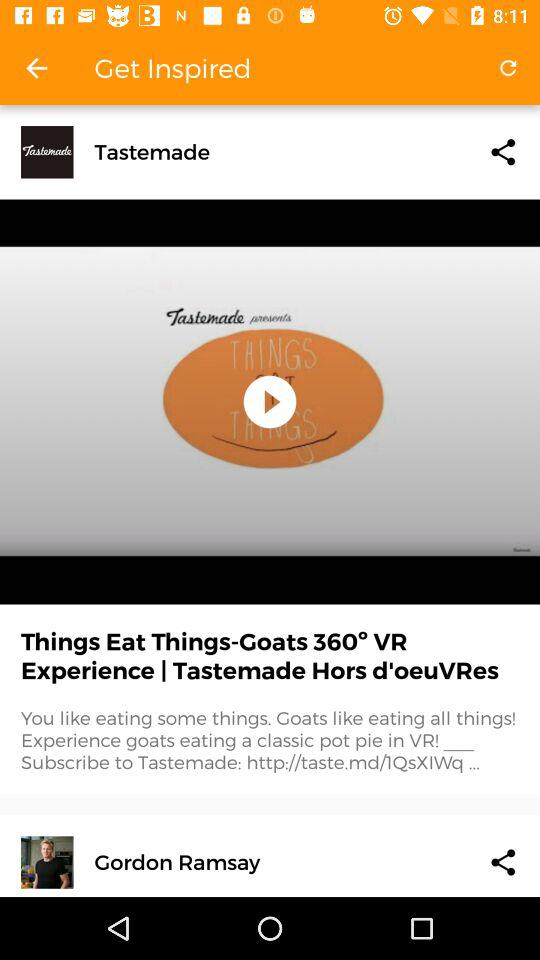What is the application name? The application name is "Tastemade". 